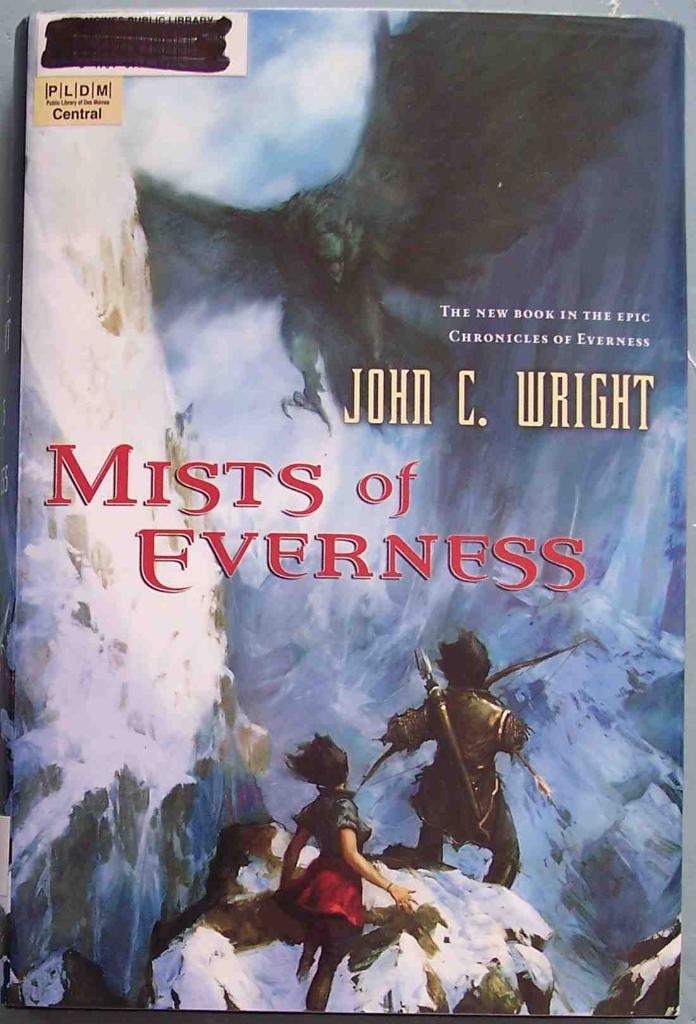<image>
Write a terse but informative summary of the picture. The book Mists of Everness was written by John C. Wright. 